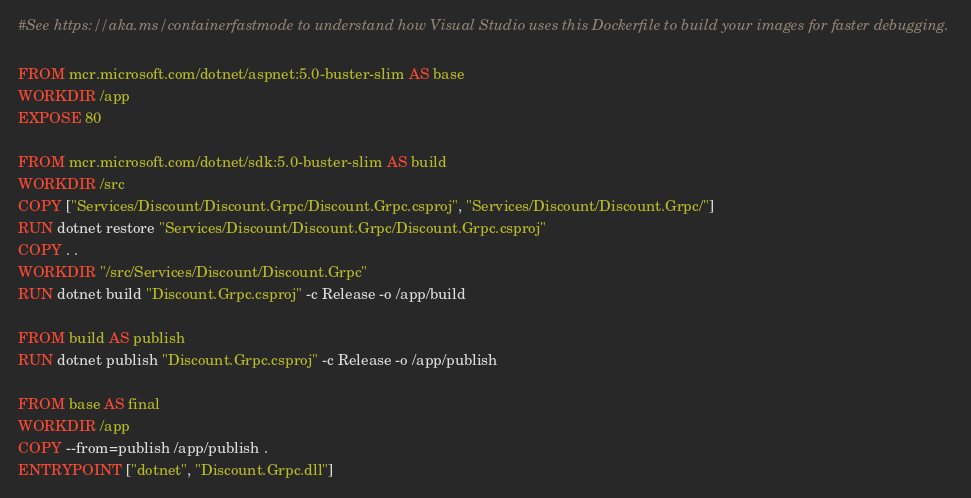<code> <loc_0><loc_0><loc_500><loc_500><_Dockerfile_>#See https://aka.ms/containerfastmode to understand how Visual Studio uses this Dockerfile to build your images for faster debugging.

FROM mcr.microsoft.com/dotnet/aspnet:5.0-buster-slim AS base
WORKDIR /app
EXPOSE 80

FROM mcr.microsoft.com/dotnet/sdk:5.0-buster-slim AS build
WORKDIR /src
COPY ["Services/Discount/Discount.Grpc/Discount.Grpc.csproj", "Services/Discount/Discount.Grpc/"]
RUN dotnet restore "Services/Discount/Discount.Grpc/Discount.Grpc.csproj"
COPY . .
WORKDIR "/src/Services/Discount/Discount.Grpc"
RUN dotnet build "Discount.Grpc.csproj" -c Release -o /app/build

FROM build AS publish
RUN dotnet publish "Discount.Grpc.csproj" -c Release -o /app/publish

FROM base AS final
WORKDIR /app
COPY --from=publish /app/publish .
ENTRYPOINT ["dotnet", "Discount.Grpc.dll"]</code> 